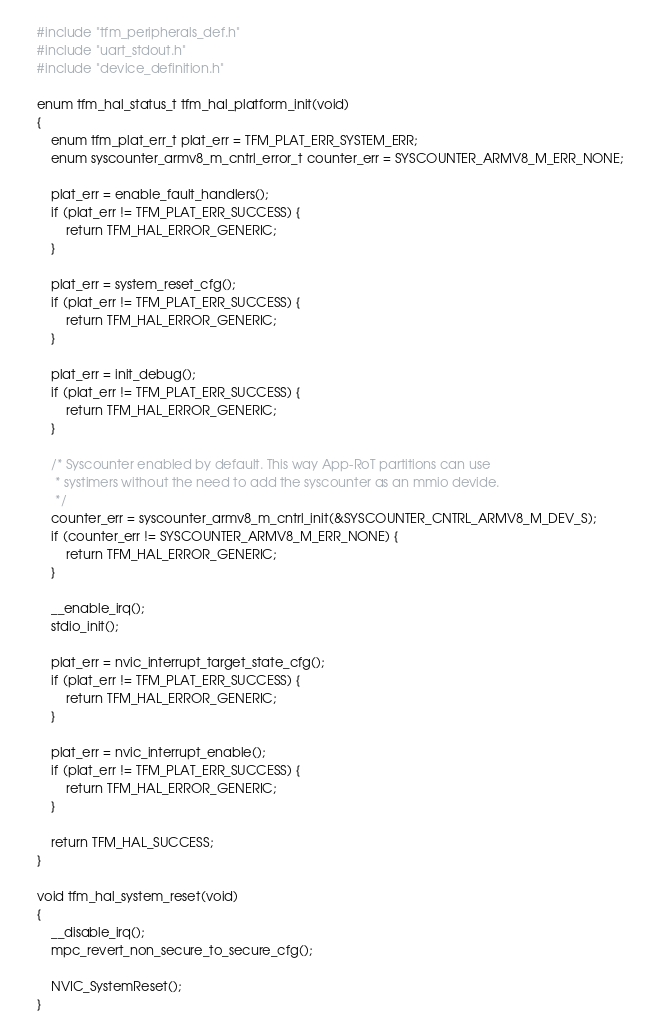Convert code to text. <code><loc_0><loc_0><loc_500><loc_500><_C_>#include "tfm_peripherals_def.h"
#include "uart_stdout.h"
#include "device_definition.h"

enum tfm_hal_status_t tfm_hal_platform_init(void)
{
    enum tfm_plat_err_t plat_err = TFM_PLAT_ERR_SYSTEM_ERR;
    enum syscounter_armv8_m_cntrl_error_t counter_err = SYSCOUNTER_ARMV8_M_ERR_NONE;

    plat_err = enable_fault_handlers();
    if (plat_err != TFM_PLAT_ERR_SUCCESS) {
        return TFM_HAL_ERROR_GENERIC;
    }

    plat_err = system_reset_cfg();
    if (plat_err != TFM_PLAT_ERR_SUCCESS) {
        return TFM_HAL_ERROR_GENERIC;
    }

    plat_err = init_debug();
    if (plat_err != TFM_PLAT_ERR_SUCCESS) {
        return TFM_HAL_ERROR_GENERIC;
    }

    /* Syscounter enabled by default. This way App-RoT partitions can use
     * systimers without the need to add the syscounter as an mmio devide.
     */
    counter_err = syscounter_armv8_m_cntrl_init(&SYSCOUNTER_CNTRL_ARMV8_M_DEV_S);
    if (counter_err != SYSCOUNTER_ARMV8_M_ERR_NONE) {
        return TFM_HAL_ERROR_GENERIC;
    }

    __enable_irq();
    stdio_init();

    plat_err = nvic_interrupt_target_state_cfg();
    if (plat_err != TFM_PLAT_ERR_SUCCESS) {
        return TFM_HAL_ERROR_GENERIC;
    }

    plat_err = nvic_interrupt_enable();
    if (plat_err != TFM_PLAT_ERR_SUCCESS) {
        return TFM_HAL_ERROR_GENERIC;
    }

    return TFM_HAL_SUCCESS;
}

void tfm_hal_system_reset(void)
{
    __disable_irq();
    mpc_revert_non_secure_to_secure_cfg();

    NVIC_SystemReset();
}
</code> 